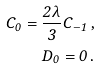Convert formula to latex. <formula><loc_0><loc_0><loc_500><loc_500>C _ { 0 } = \frac { 2 \lambda } { 3 } C _ { - 1 } \, , \\ D _ { 0 } = 0 \, .</formula> 